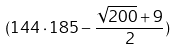Convert formula to latex. <formula><loc_0><loc_0><loc_500><loc_500>( 1 4 4 \cdot 1 8 5 - \frac { \sqrt { 2 0 0 } + 9 } { 2 } )</formula> 